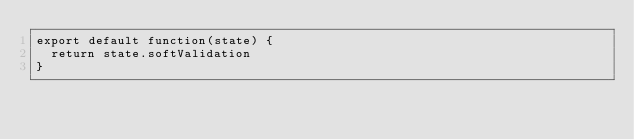<code> <loc_0><loc_0><loc_500><loc_500><_JavaScript_>export default function(state) {
  return state.softValidation
}
</code> 